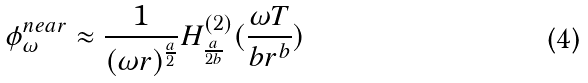<formula> <loc_0><loc_0><loc_500><loc_500>\phi _ { \omega } ^ { n e a r } \approx \frac { 1 } { ( \omega r ) ^ { \frac { a } { 2 } } } H _ { \frac { a } { 2 b } } ^ { ( 2 ) } ( \frac { \omega T } { b r ^ { b } } )</formula> 